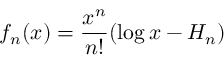<formula> <loc_0><loc_0><loc_500><loc_500>f _ { n } ( x ) = { \frac { x ^ { n } } { n ! } } ( \log x - H _ { n } )</formula> 